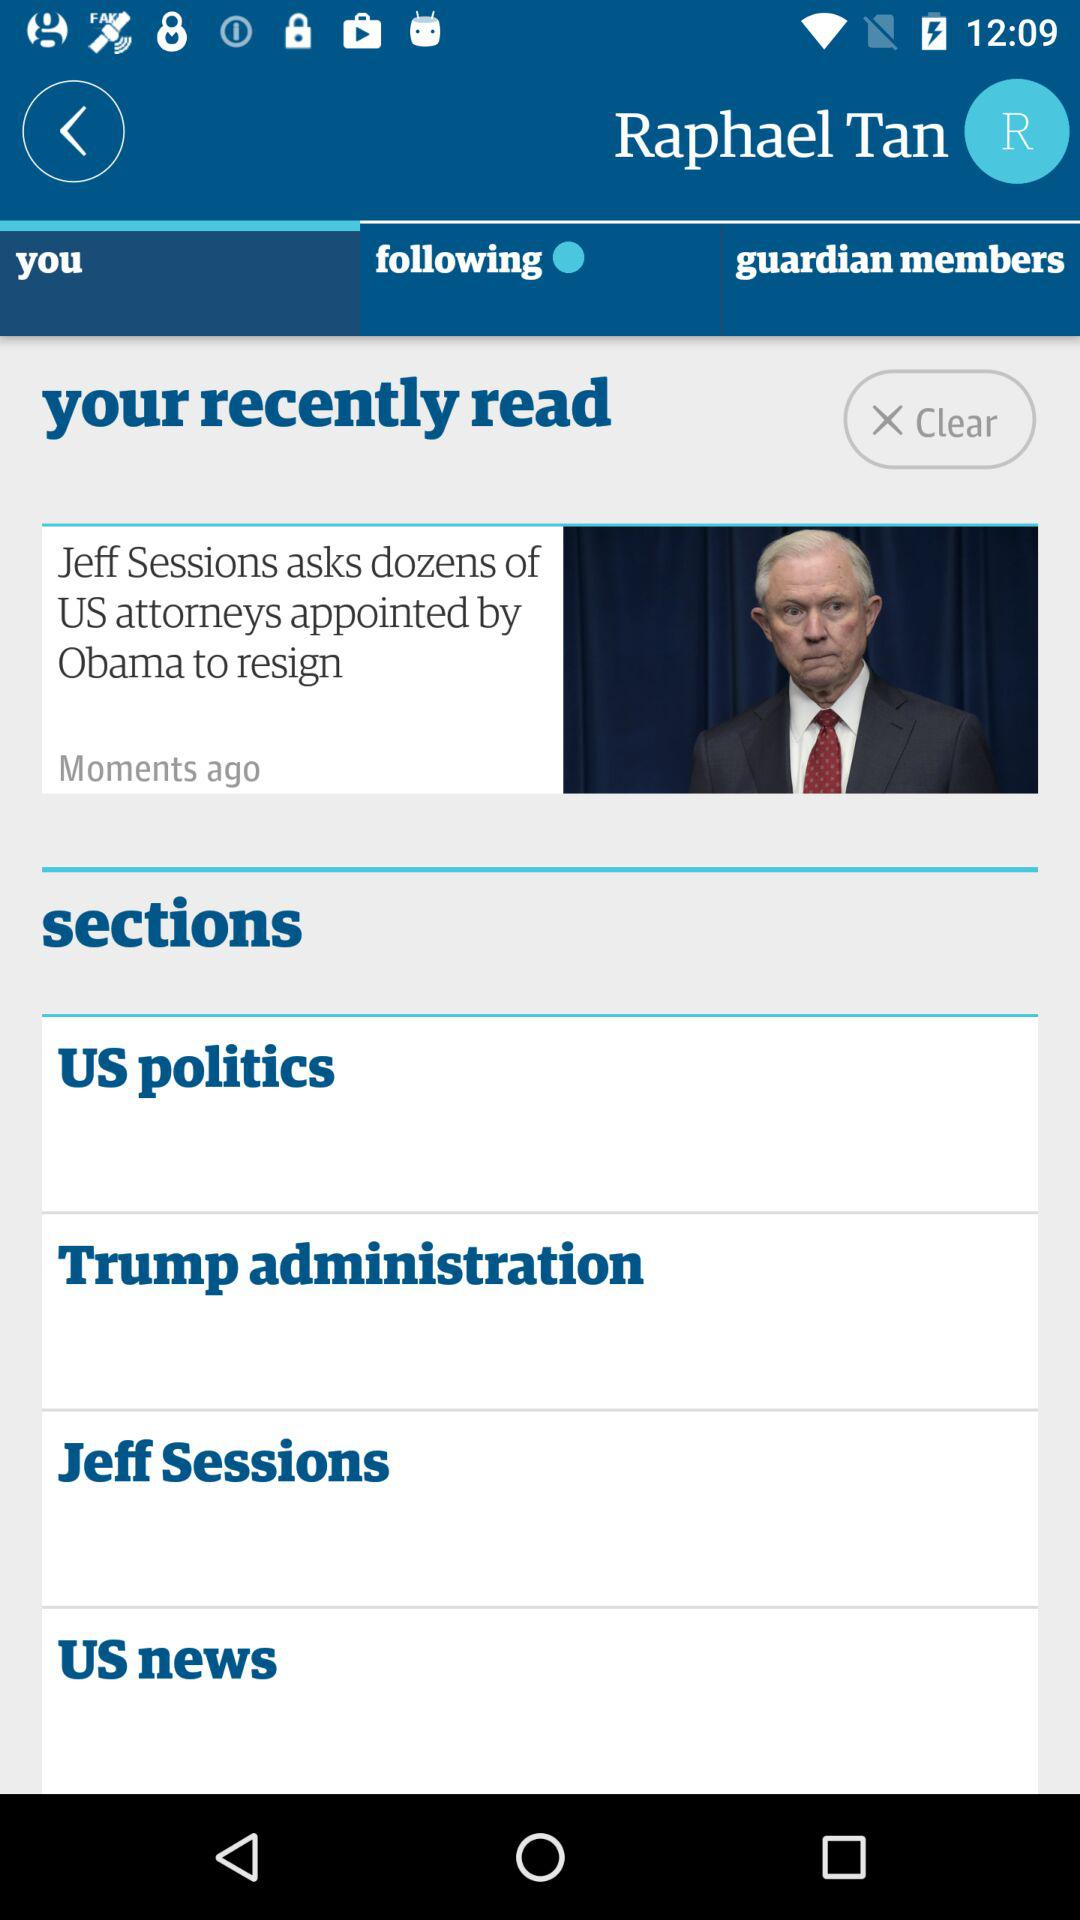What is the user name? The user name is Raphael Tan. 